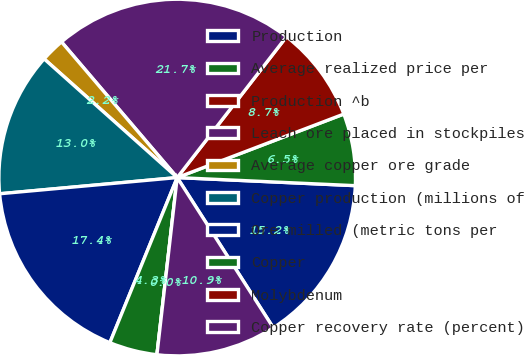Convert chart to OTSL. <chart><loc_0><loc_0><loc_500><loc_500><pie_chart><fcel>Production<fcel>Average realized price per<fcel>Production ^b<fcel>Leach ore placed in stockpiles<fcel>Average copper ore grade<fcel>Copper production (millions of<fcel>Ore milled (metric tons per<fcel>Copper<fcel>Molybdenum<fcel>Copper recovery rate (percent)<nl><fcel>15.22%<fcel>6.52%<fcel>8.7%<fcel>21.74%<fcel>2.17%<fcel>13.04%<fcel>17.39%<fcel>4.35%<fcel>0.0%<fcel>10.87%<nl></chart> 